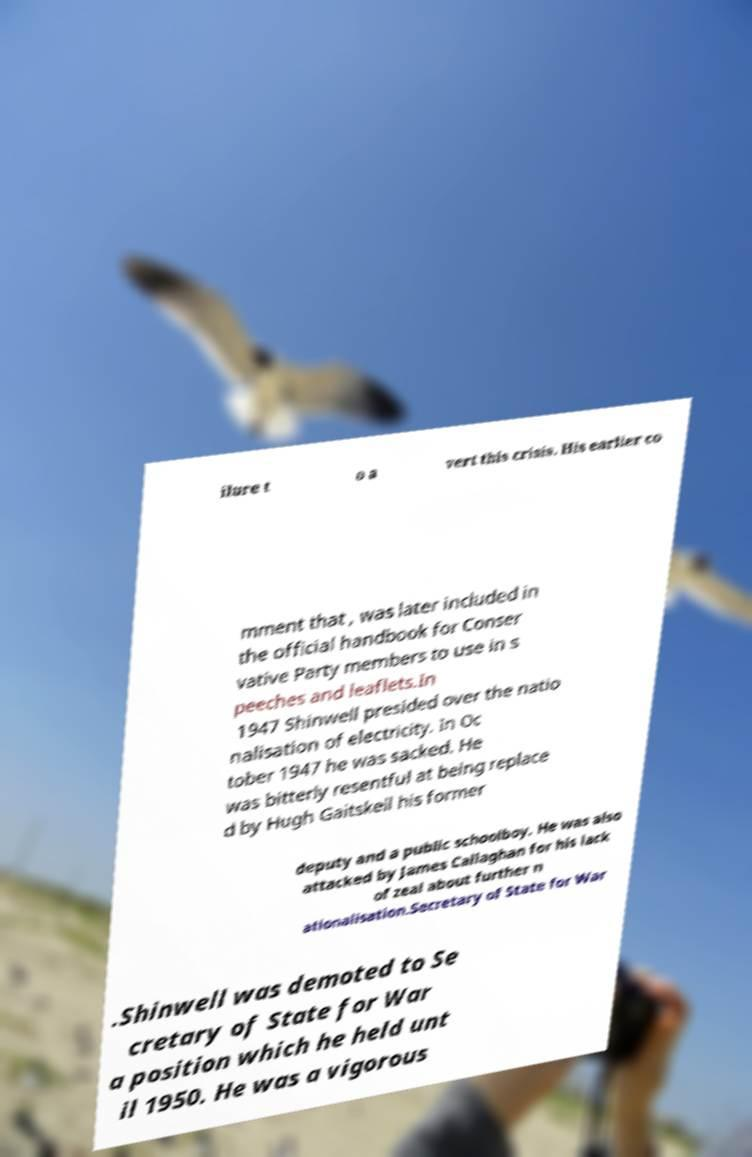Could you assist in decoding the text presented in this image and type it out clearly? ilure t o a vert this crisis. His earlier co mment that , was later included in the official handbook for Conser vative Party members to use in s peeches and leaflets.In 1947 Shinwell presided over the natio nalisation of electricity. In Oc tober 1947 he was sacked. He was bitterly resentful at being replace d by Hugh Gaitskell his former deputy and a public schoolboy. He was also attacked by James Callaghan for his lack of zeal about further n ationalisation.Secretary of State for War .Shinwell was demoted to Se cretary of State for War a position which he held unt il 1950. He was a vigorous 